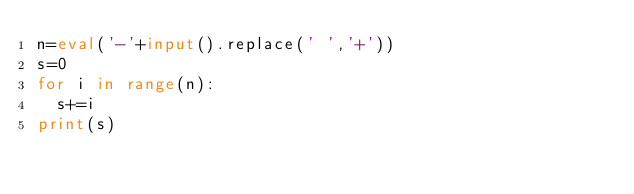<code> <loc_0><loc_0><loc_500><loc_500><_Python_>n=eval('-'+input().replace(' ','+'))
s=0
for i in range(n):
  s+=i
print(s)</code> 